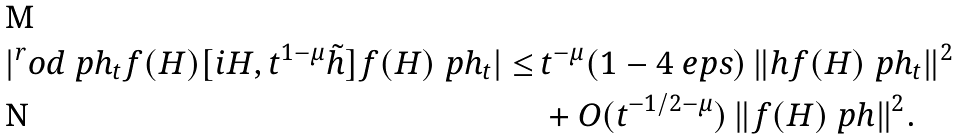<formula> <loc_0><loc_0><loc_500><loc_500>| ^ { r } o d { \ p h _ { t } } { f ( H ) [ i H , t ^ { 1 - \mu } \tilde { h } ] f ( H ) \ p h _ { t } } | \leq \, & t ^ { - \mu } ( 1 - 4 \ e p s ) \, \| h f ( H ) \ p h _ { t } \| ^ { 2 } \\ & + O ( t ^ { - 1 / 2 - \mu } ) \, \| f ( H ) \ p h \| ^ { 2 } .</formula> 